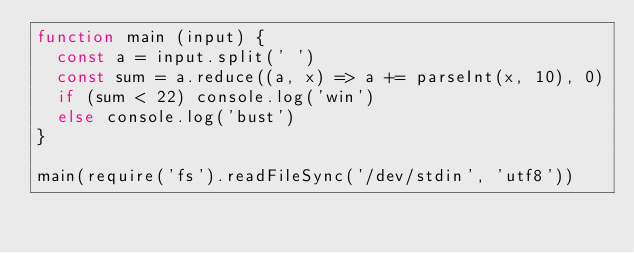<code> <loc_0><loc_0><loc_500><loc_500><_JavaScript_>function main (input) {
  const a = input.split(' ')
  const sum = a.reduce((a, x) => a += parseInt(x, 10), 0)
  if (sum < 22) console.log('win')
  else console.log('bust')
}

main(require('fs').readFileSync('/dev/stdin', 'utf8'))
</code> 